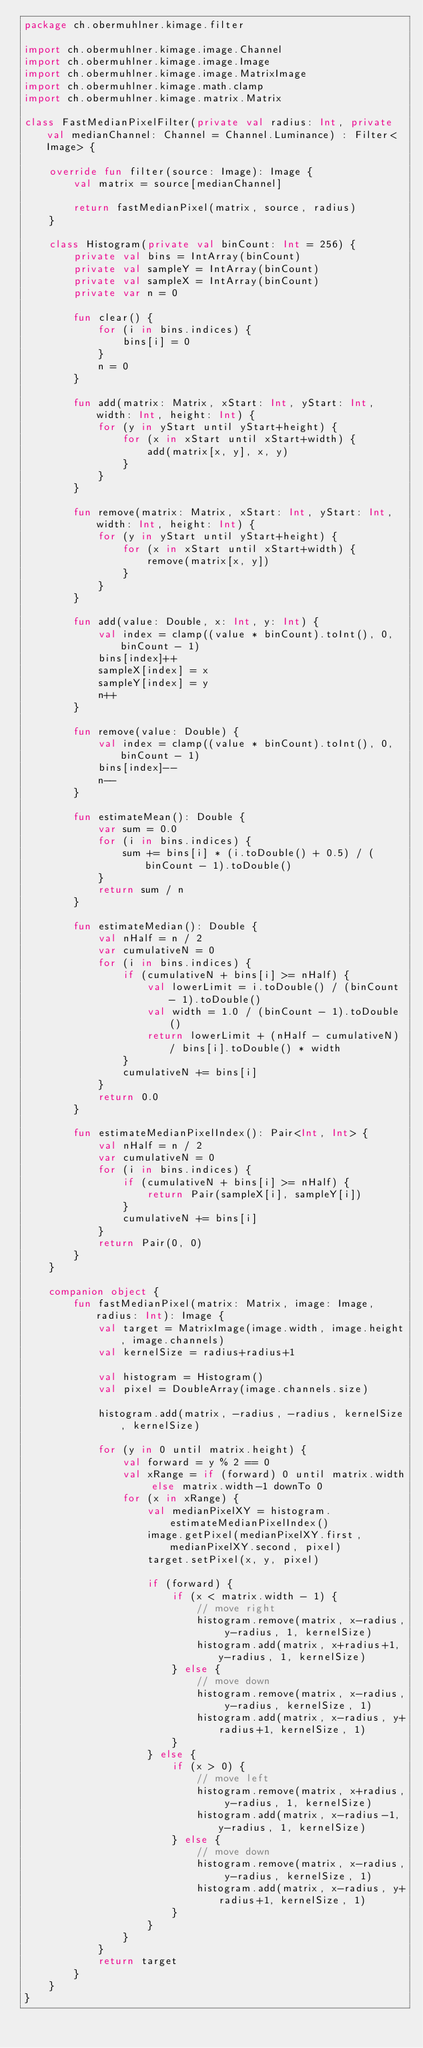Convert code to text. <code><loc_0><loc_0><loc_500><loc_500><_Kotlin_>package ch.obermuhlner.kimage.filter

import ch.obermuhlner.kimage.image.Channel
import ch.obermuhlner.kimage.image.Image
import ch.obermuhlner.kimage.image.MatrixImage
import ch.obermuhlner.kimage.math.clamp
import ch.obermuhlner.kimage.matrix.Matrix

class FastMedianPixelFilter(private val radius: Int, private val medianChannel: Channel = Channel.Luminance) : Filter<Image> {

    override fun filter(source: Image): Image {
        val matrix = source[medianChannel]

        return fastMedianPixel(matrix, source, radius)
    }

    class Histogram(private val binCount: Int = 256) {
        private val bins = IntArray(binCount)
        private val sampleY = IntArray(binCount)
        private val sampleX = IntArray(binCount)
        private var n = 0

        fun clear() {
            for (i in bins.indices) {
                bins[i] = 0
            }
            n = 0
        }

        fun add(matrix: Matrix, xStart: Int, yStart: Int, width: Int, height: Int) {
            for (y in yStart until yStart+height) {
                for (x in xStart until xStart+width) {
                    add(matrix[x, y], x, y)
                }
            }
        }

        fun remove(matrix: Matrix, xStart: Int, yStart: Int, width: Int, height: Int) {
            for (y in yStart until yStart+height) {
                for (x in xStart until xStart+width) {
                    remove(matrix[x, y])
                }
            }
        }

        fun add(value: Double, x: Int, y: Int) {
            val index = clamp((value * binCount).toInt(), 0, binCount - 1)
            bins[index]++
            sampleX[index] = x
            sampleY[index] = y
            n++
        }

        fun remove(value: Double) {
            val index = clamp((value * binCount).toInt(), 0, binCount - 1)
            bins[index]--
            n--
        }

        fun estimateMean(): Double {
            var sum = 0.0
            for (i in bins.indices) {
                sum += bins[i] * (i.toDouble() + 0.5) / (binCount - 1).toDouble()
            }
            return sum / n
        }

        fun estimateMedian(): Double {
            val nHalf = n / 2
            var cumulativeN = 0
            for (i in bins.indices) {
                if (cumulativeN + bins[i] >= nHalf) {
                    val lowerLimit = i.toDouble() / (binCount - 1).toDouble()
                    val width = 1.0 / (binCount - 1).toDouble()
                    return lowerLimit + (nHalf - cumulativeN) / bins[i].toDouble() * width
                }
                cumulativeN += bins[i]
            }
            return 0.0
        }

        fun estimateMedianPixelIndex(): Pair<Int, Int> {
            val nHalf = n / 2
            var cumulativeN = 0
            for (i in bins.indices) {
                if (cumulativeN + bins[i] >= nHalf) {
                    return Pair(sampleX[i], sampleY[i])
                }
                cumulativeN += bins[i]
            }
            return Pair(0, 0)
        }
    }

    companion object {
        fun fastMedianPixel(matrix: Matrix, image: Image, radius: Int): Image {
            val target = MatrixImage(image.width, image.height, image.channels)
            val kernelSize = radius+radius+1

            val histogram = Histogram()
            val pixel = DoubleArray(image.channels.size)

            histogram.add(matrix, -radius, -radius, kernelSize, kernelSize)

            for (y in 0 until matrix.height) {
                val forward = y % 2 == 0
                val xRange = if (forward) 0 until matrix.width else matrix.width-1 downTo 0
                for (x in xRange) {
                    val medianPixelXY = histogram.estimateMedianPixelIndex()
                    image.getPixel(medianPixelXY.first, medianPixelXY.second, pixel)
                    target.setPixel(x, y, pixel)

                    if (forward) {
                        if (x < matrix.width - 1) {
                            // move right
                            histogram.remove(matrix, x-radius, y-radius, 1, kernelSize)
                            histogram.add(matrix, x+radius+1, y-radius, 1, kernelSize)
                        } else {
                            // move down
                            histogram.remove(matrix, x-radius, y-radius, kernelSize, 1)
                            histogram.add(matrix, x-radius, y+radius+1, kernelSize, 1)
                        }
                    } else {
                        if (x > 0) {
                            // move left
                            histogram.remove(matrix, x+radius, y-radius, 1, kernelSize)
                            histogram.add(matrix, x-radius-1, y-radius, 1, kernelSize)
                        } else {
                            // move down
                            histogram.remove(matrix, x-radius, y-radius, kernelSize, 1)
                            histogram.add(matrix, x-radius, y+radius+1, kernelSize, 1)
                        }
                    }
                }
            }
            return target
        }
    }
}</code> 